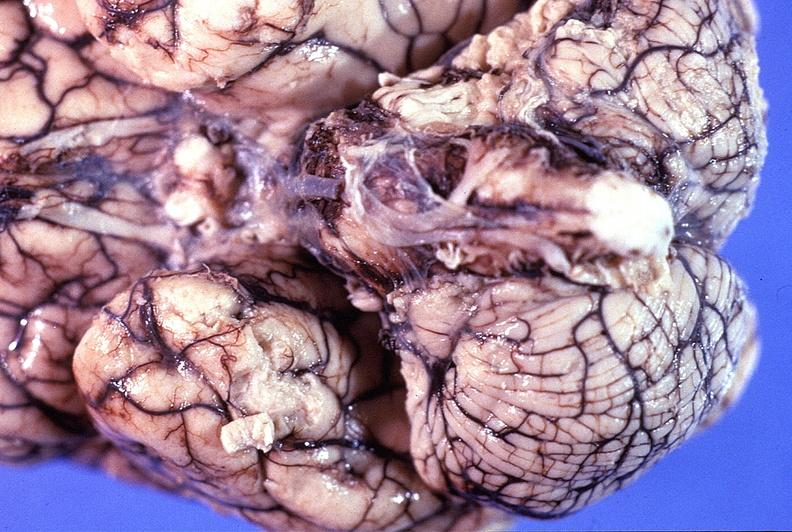does carcinomatosis show normal brain?
Answer the question using a single word or phrase. No 